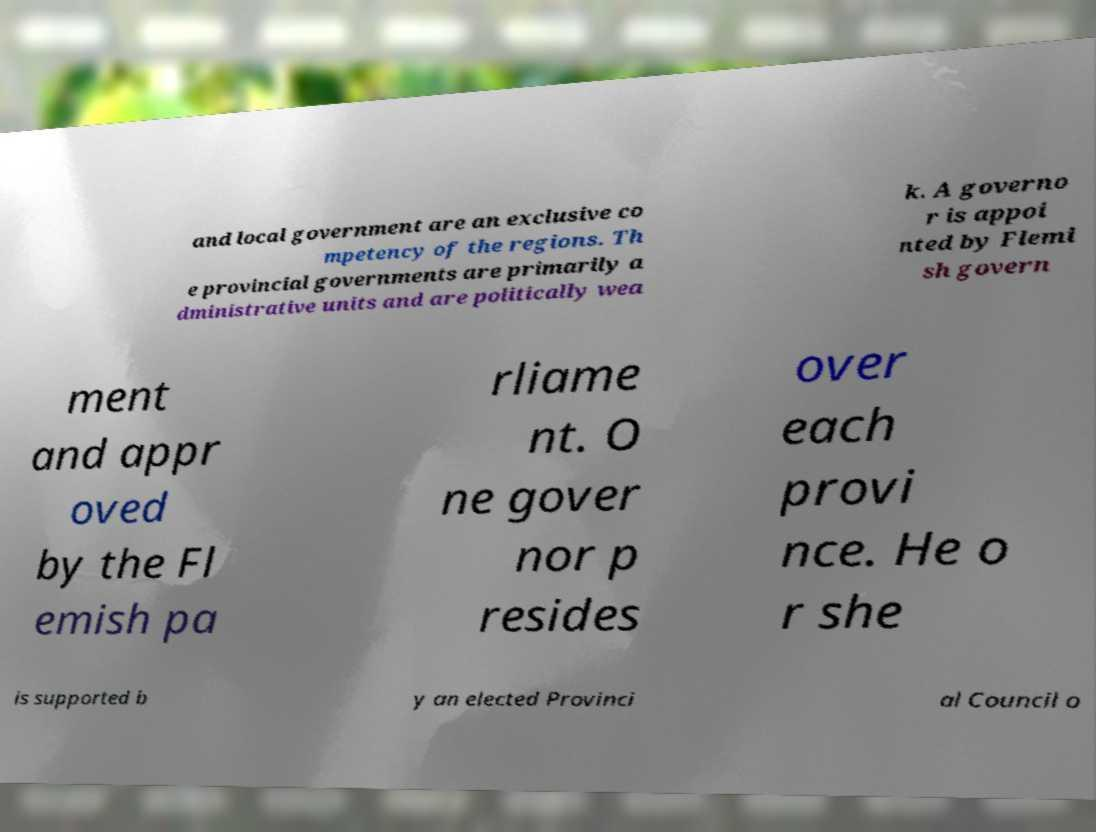Can you read and provide the text displayed in the image?This photo seems to have some interesting text. Can you extract and type it out for me? and local government are an exclusive co mpetency of the regions. Th e provincial governments are primarily a dministrative units and are politically wea k. A governo r is appoi nted by Flemi sh govern ment and appr oved by the Fl emish pa rliame nt. O ne gover nor p resides over each provi nce. He o r she is supported b y an elected Provinci al Council o 